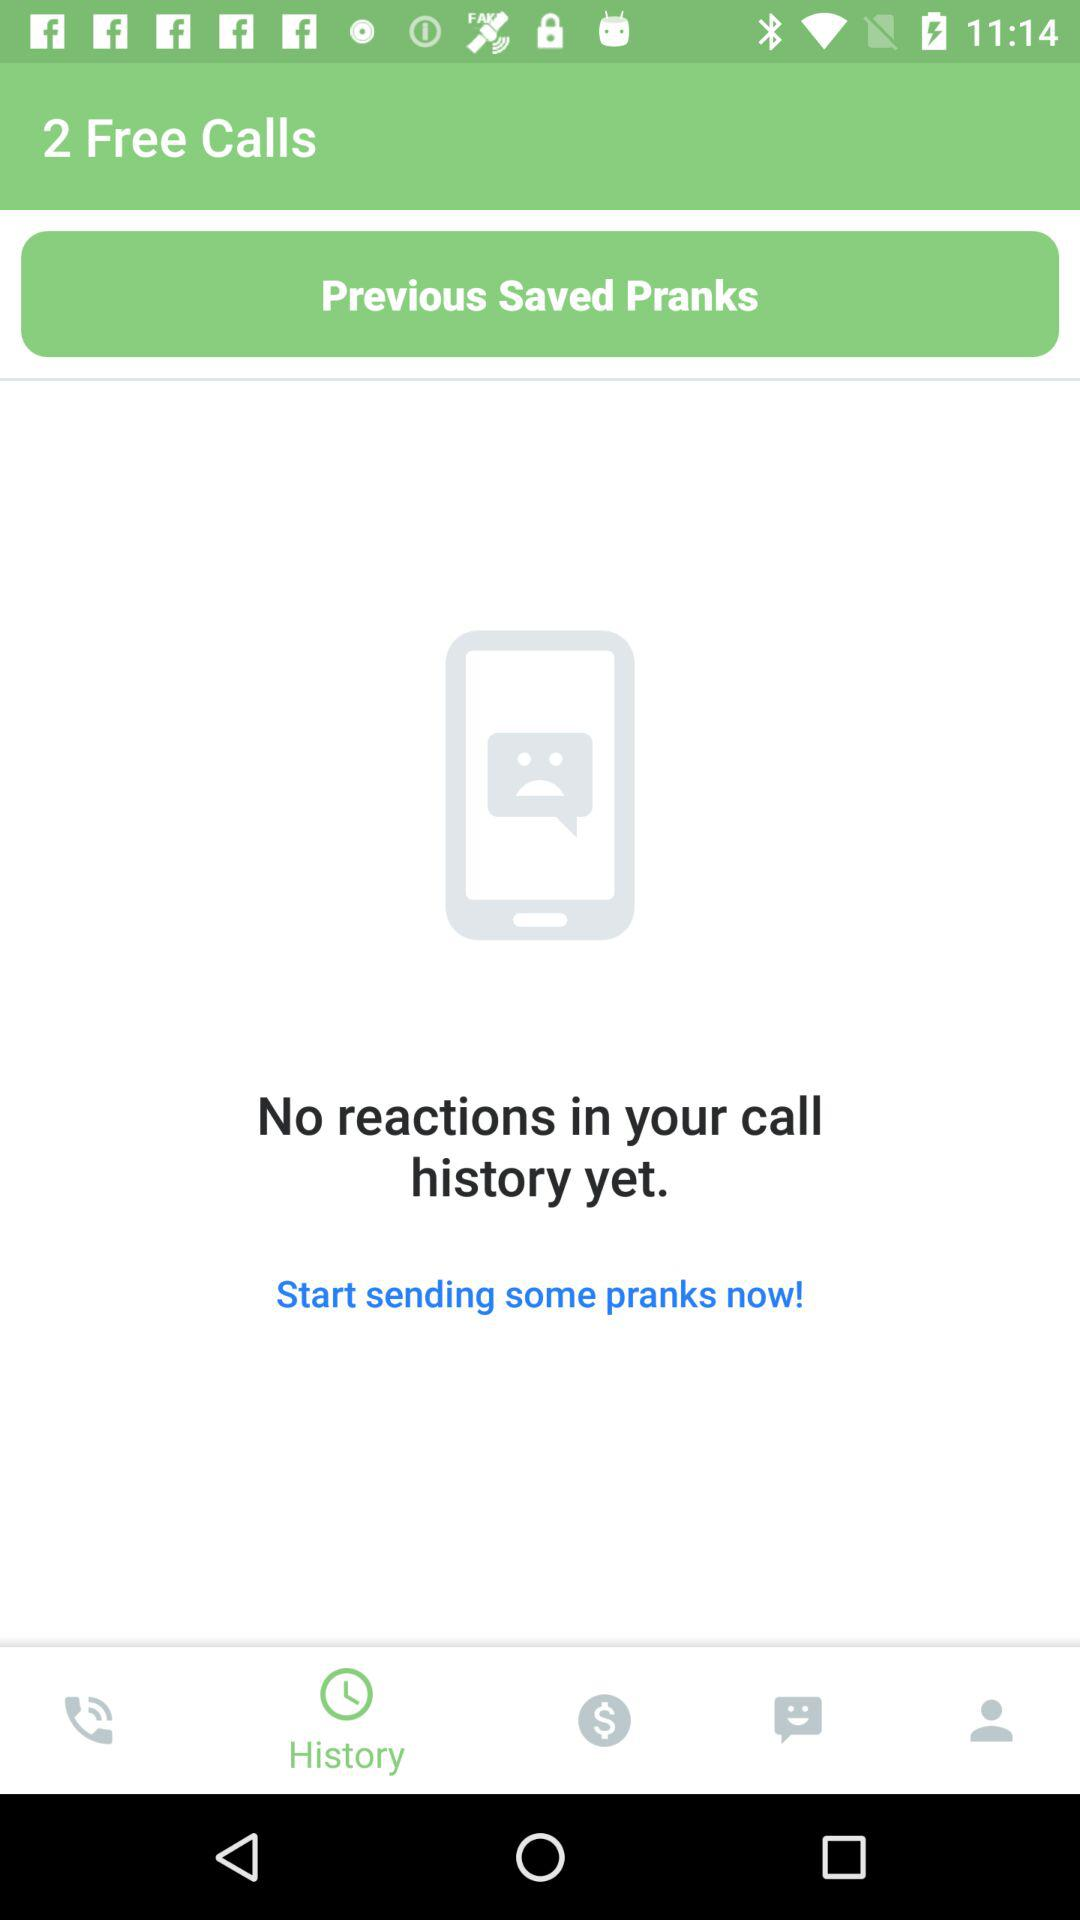What is the selected tab? The selected tab is "History". 